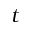<formula> <loc_0><loc_0><loc_500><loc_500>t</formula> 